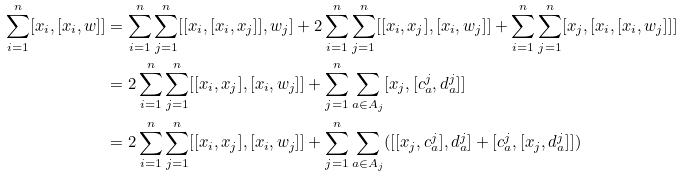Convert formula to latex. <formula><loc_0><loc_0><loc_500><loc_500>\sum _ { i = 1 } ^ { n } [ x _ { i } , [ x _ { i } , w ] ] & = \sum _ { i = 1 } ^ { n } \sum _ { j = 1 } ^ { n } [ [ x _ { i } , [ x _ { i } , x _ { j } ] ] , w _ { j } ] + 2 \sum _ { i = 1 } ^ { n } \sum _ { j = 1 } ^ { n } [ [ x _ { i } , x _ { j } ] , [ x _ { i } , w _ { j } ] ] + \sum _ { i = 1 } ^ { n } \sum _ { j = 1 } ^ { n } [ x _ { j } , [ x _ { i } , [ x _ { i } , w _ { j } ] ] ] \\ & = 2 \sum _ { i = 1 } ^ { n } \sum _ { j = 1 } ^ { n } [ [ x _ { i } , x _ { j } ] , [ x _ { i } , w _ { j } ] ] + \sum _ { j = 1 } ^ { n } \sum _ { a \in A _ { j } } [ x _ { j } , [ c _ { a } ^ { j } , d _ { a } ^ { j } ] ] \\ & = 2 \sum _ { i = 1 } ^ { n } \sum _ { j = 1 } ^ { n } [ [ x _ { i } , x _ { j } ] , [ x _ { i } , w _ { j } ] ] + \sum _ { j = 1 } ^ { n } \sum _ { a \in A _ { j } } ( [ [ x _ { j } , c _ { a } ^ { j } ] , d _ { a } ^ { j } ] + [ c _ { a } ^ { j } , [ x _ { j } , d _ { a } ^ { j } ] ] )</formula> 